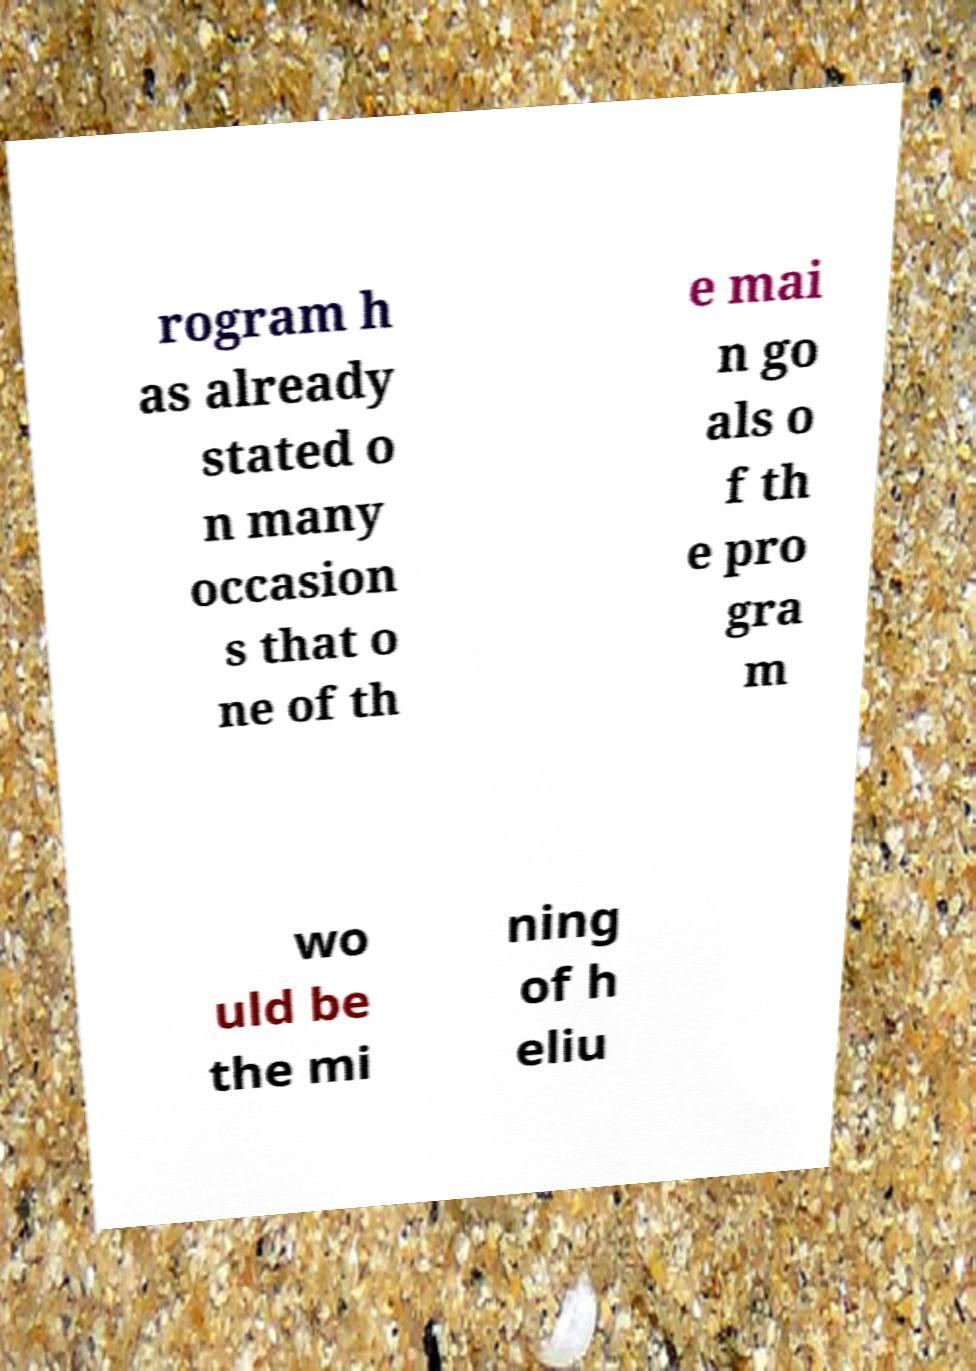Please read and relay the text visible in this image. What does it say? rogram h as already stated o n many occasion s that o ne of th e mai n go als o f th e pro gra m wo uld be the mi ning of h eliu 